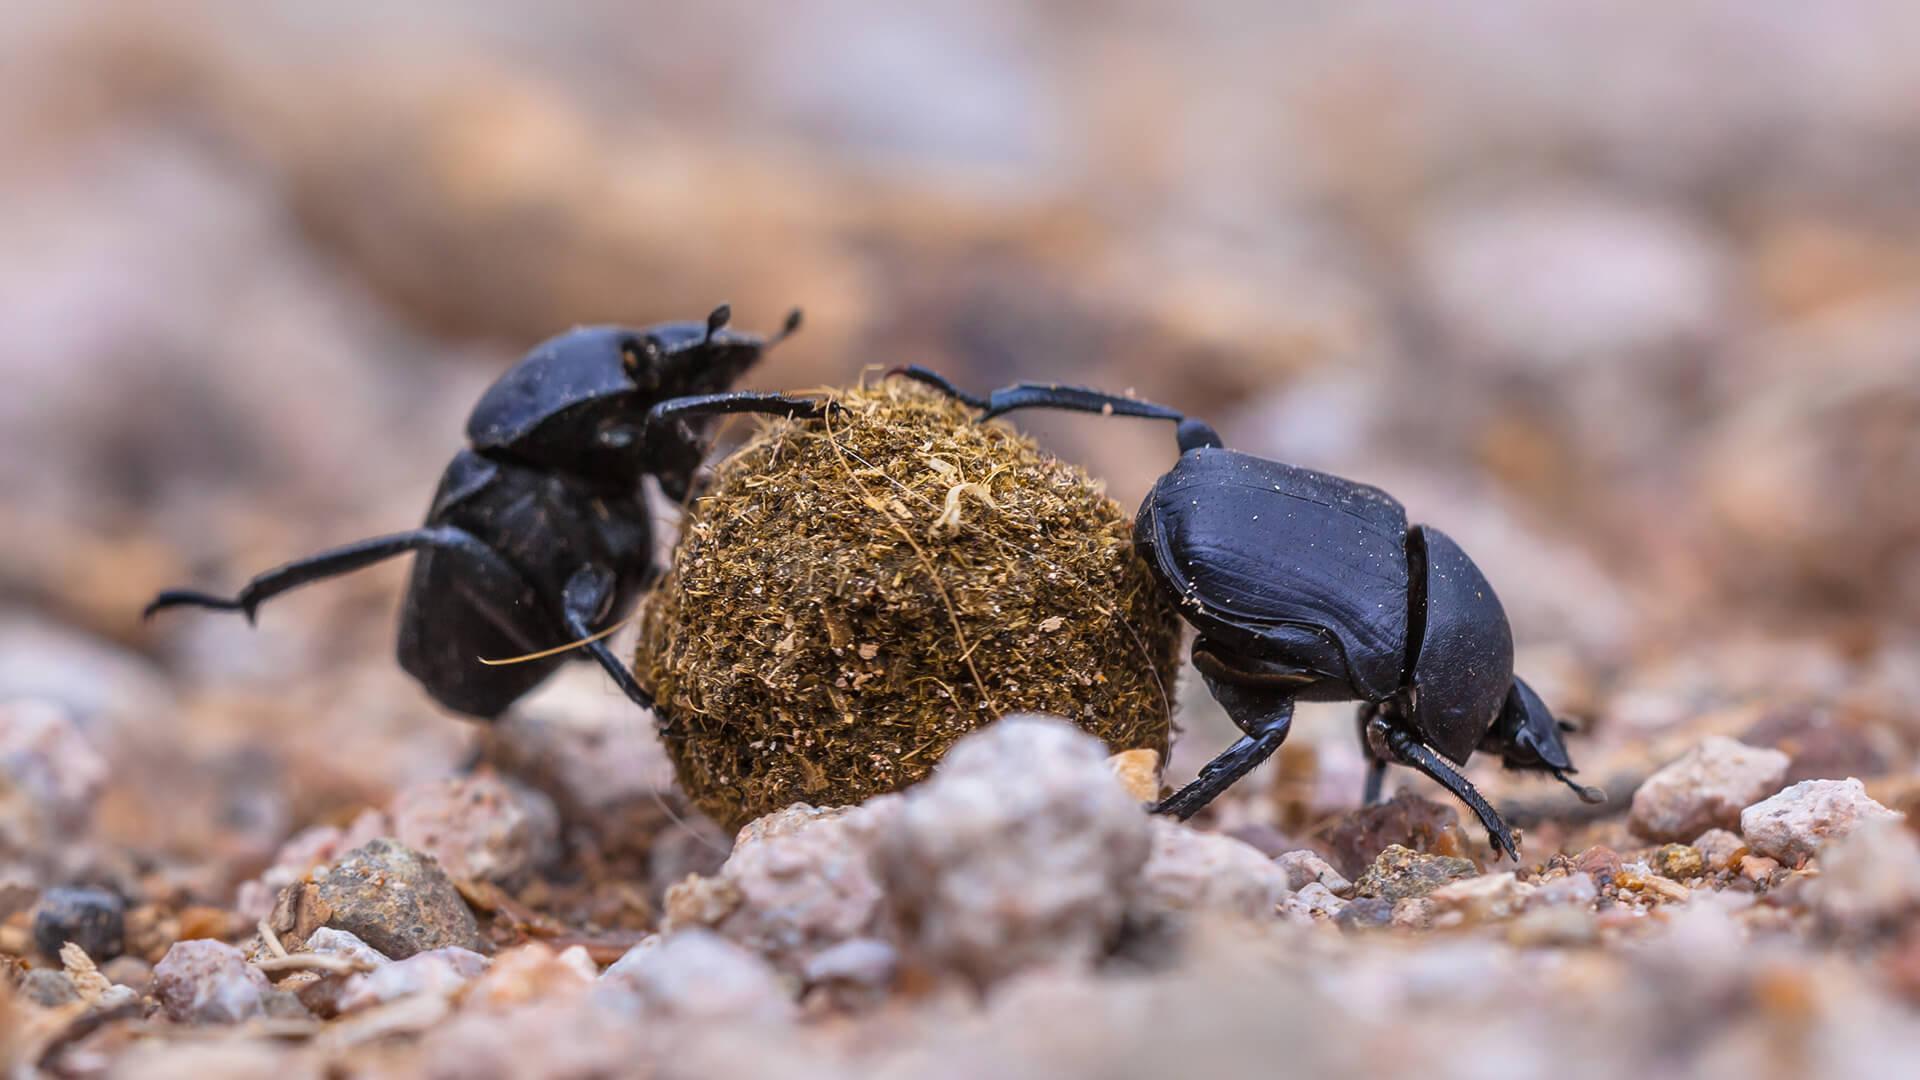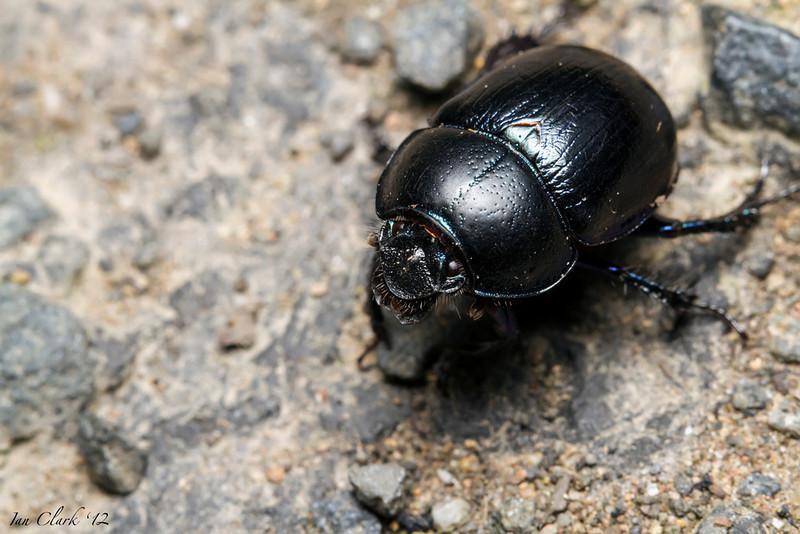The first image is the image on the left, the second image is the image on the right. Evaluate the accuracy of this statement regarding the images: "The right image contains a dung ball.". Is it true? Answer yes or no. No. 